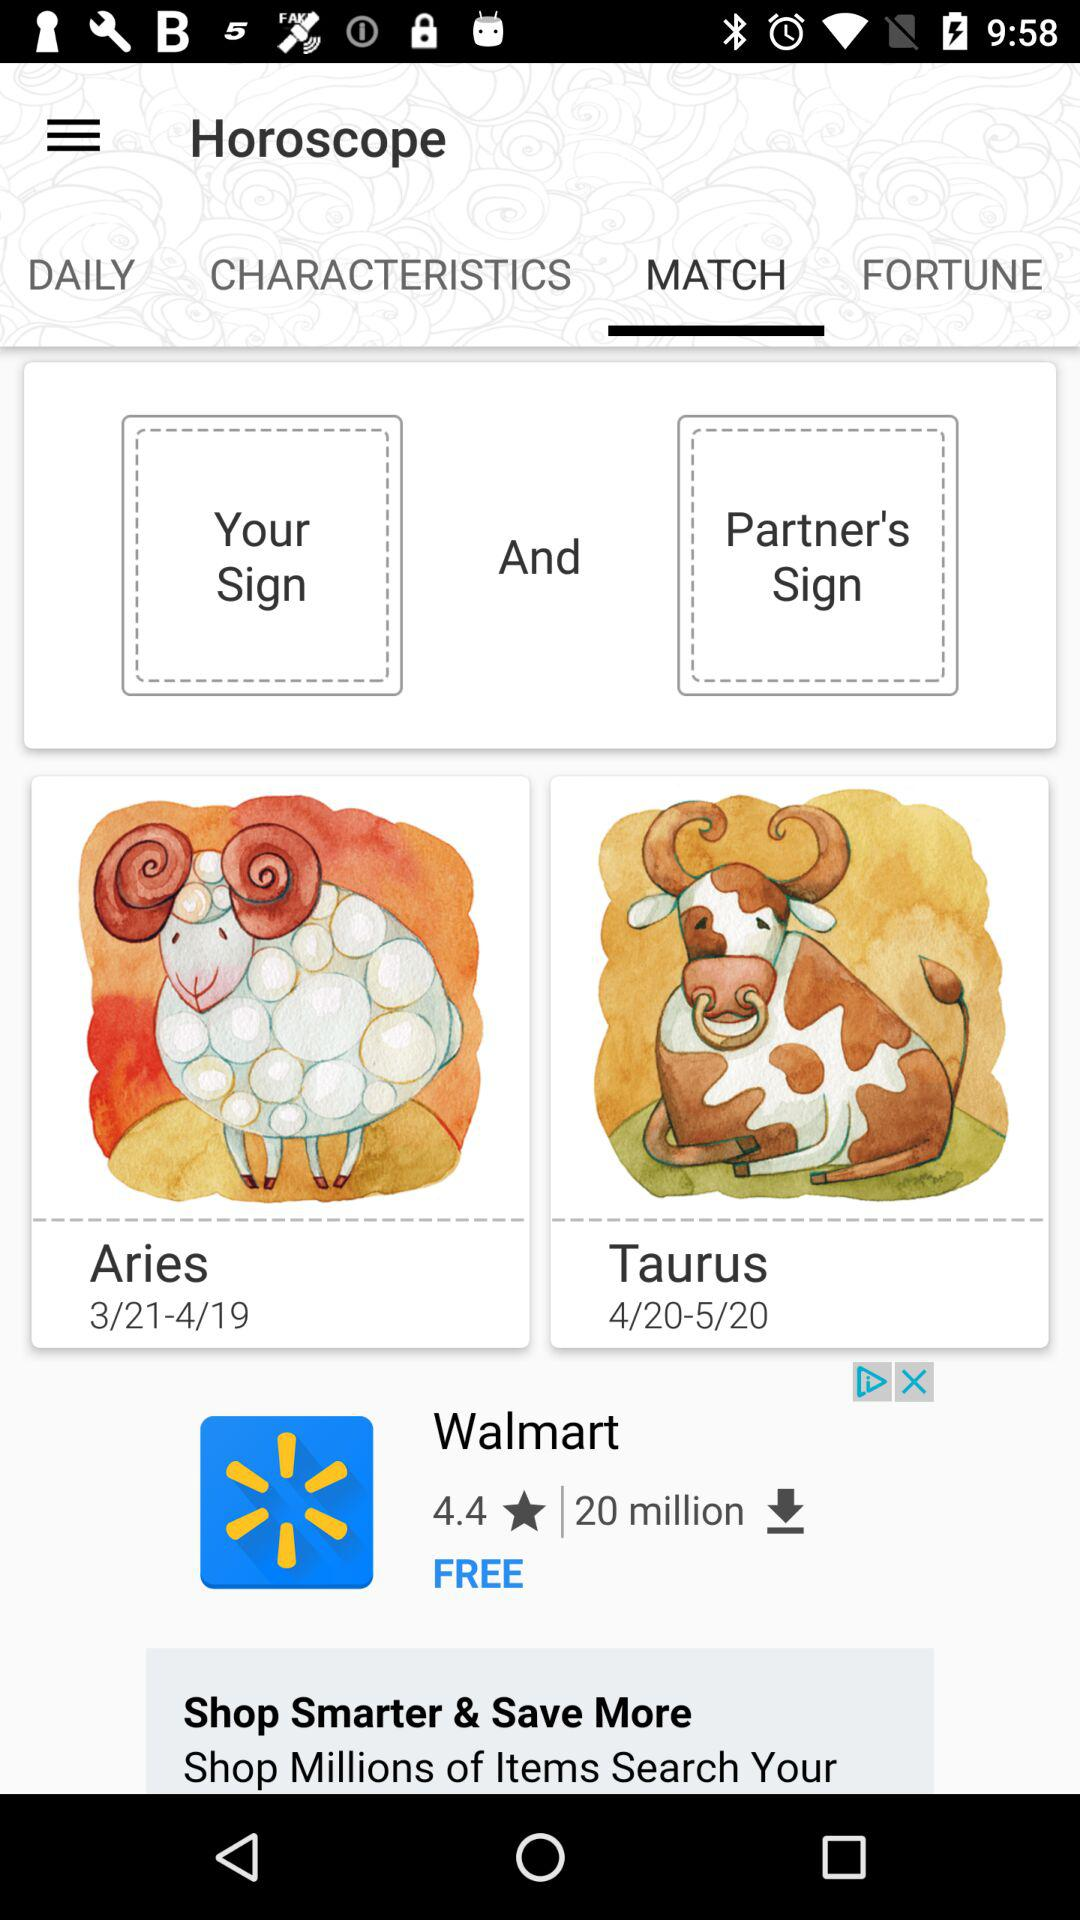What's the mentioned date range for the horoscope for Taurus? The mentioned date range for the horoscope for Taurus is April 20 to May 20. 